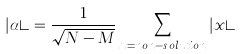Convert formula to latex. <formula><loc_0><loc_0><loc_500><loc_500>| \alpha \rangle = \frac { 1 } { \sqrt { N - M } } \sum _ { x = n o n - s o l u t i o n } | x \rangle</formula> 